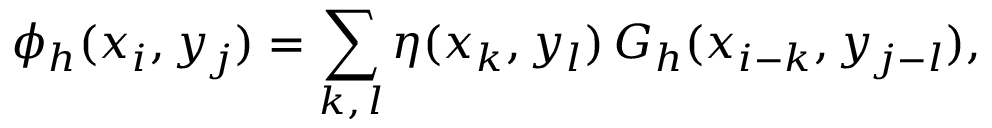Convert formula to latex. <formula><loc_0><loc_0><loc_500><loc_500>\phi _ { h } ( x _ { i } , y _ { j } ) = \sum _ { k , \, l } \eta ( x _ { k } , y _ { l } ) \, G _ { h } ( x _ { i - k } , y _ { j - l } ) ,</formula> 